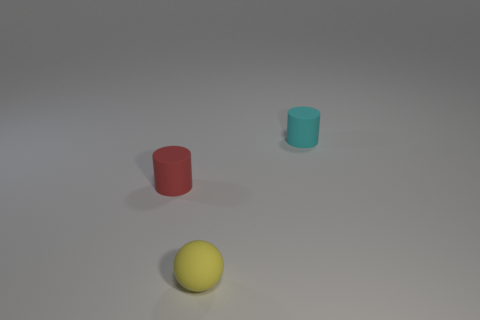Are there fewer small red objects that are behind the cyan rubber object than red matte objects on the left side of the tiny yellow thing?
Give a very brief answer. Yes. Do the cyan cylinder and the cylinder on the left side of the tiny yellow matte ball have the same size?
Give a very brief answer. Yes. The small object that is behind the tiny rubber sphere and right of the tiny red rubber cylinder has what shape?
Provide a succinct answer. Cylinder. What is the size of the cyan cylinder that is the same material as the tiny yellow sphere?
Your response must be concise. Small. How many tiny cyan matte cylinders are in front of the tiny matte object in front of the red rubber cylinder?
Ensure brevity in your answer.  0. Is the material of the cylinder that is in front of the cyan cylinder the same as the yellow thing?
Your answer should be very brief. Yes. Is there anything else that has the same material as the tiny cyan object?
Your response must be concise. Yes. What size is the cylinder that is to the right of the small rubber object that is left of the matte ball?
Ensure brevity in your answer.  Small. There is a yellow rubber thing that is to the left of the cylinder behind the rubber cylinder to the left of the tiny yellow ball; what is its size?
Offer a very short reply. Small. There is a tiny rubber object that is on the right side of the yellow ball; is it the same shape as the thing left of the rubber ball?
Ensure brevity in your answer.  Yes. 